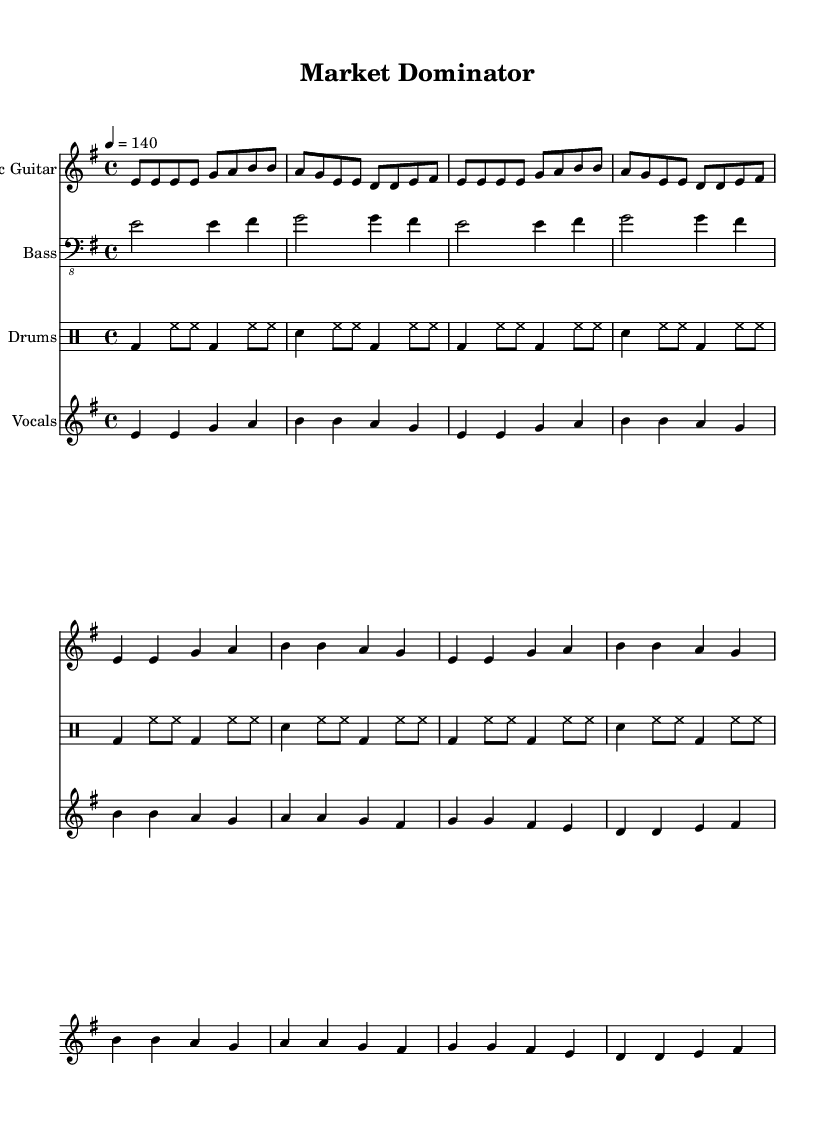What is the key signature of this music? The key signature is indicated by the key signature at the beginning of the music. In this case, it is indicated as E minor, which has one sharp (F#).
Answer: E minor What is the time signature of this music? The time signature is found at the beginning of the staff and is displayed as 4/4. This indicates that there are four beats per measure and the quarter note gets one beat.
Answer: 4/4 What is the tempo marking for this piece? The tempo marking is found at the beginning of the score and is indicated as 140 beats per minute (BPM). This means the music should be played at a fast pace.
Answer: 140 How many times is the electric guitar part repeated in the score? The electric guitar part has a repeat indication shown by the word "repeat" and the number "2," which communicates that the passage should be played twice.
Answer: 2 What do the lyrics of the chorus emphasize? The chorus lyrics emphasize being a "market dominator" and breaking barriers, which reflect the themes of overcoming challenges and competition in a market context.
Answer: Market dominator What is the pattern of the bass guitar part? The bass guitar part consists of two measures repeated, where each measure is structured with specific note values that support the harmonic progression. The repeat indication shows this clearly.
Answer: Repeat How does the drum part support the intensity of the piece? The drum part features a steady beat structure with bass drum and snare hits that complement the energy of the electric guitar and vocals, creating a driving force typical in hard rock music.
Answer: Driving force 